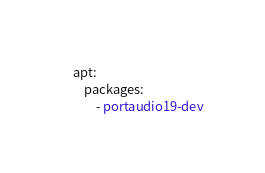<code> <loc_0><loc_0><loc_500><loc_500><_YAML_>    apt:
        packages:
            - portaudio19-dev
</code> 